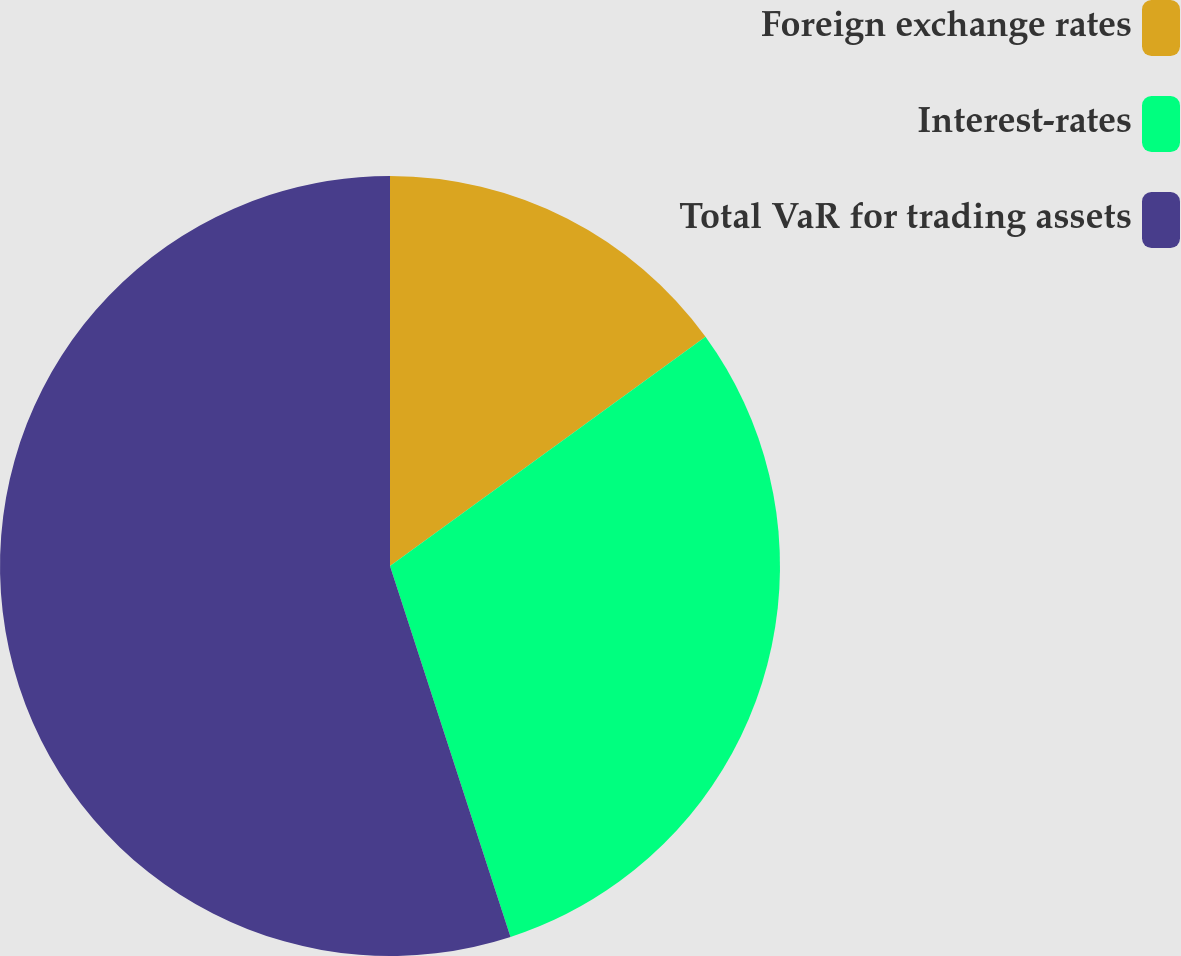Convert chart. <chart><loc_0><loc_0><loc_500><loc_500><pie_chart><fcel>Foreign exchange rates<fcel>Interest-rates<fcel>Total VaR for trading assets<nl><fcel>15.0%<fcel>30.0%<fcel>55.0%<nl></chart> 